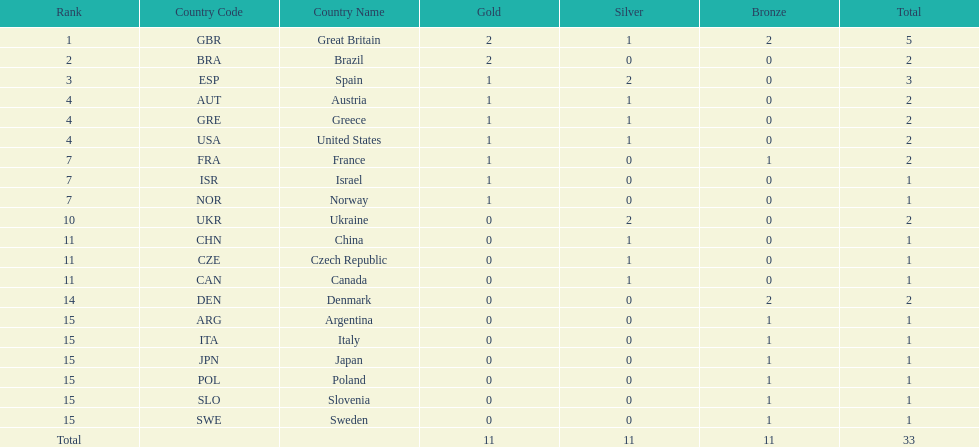What country had the most medals? Great Britain. 